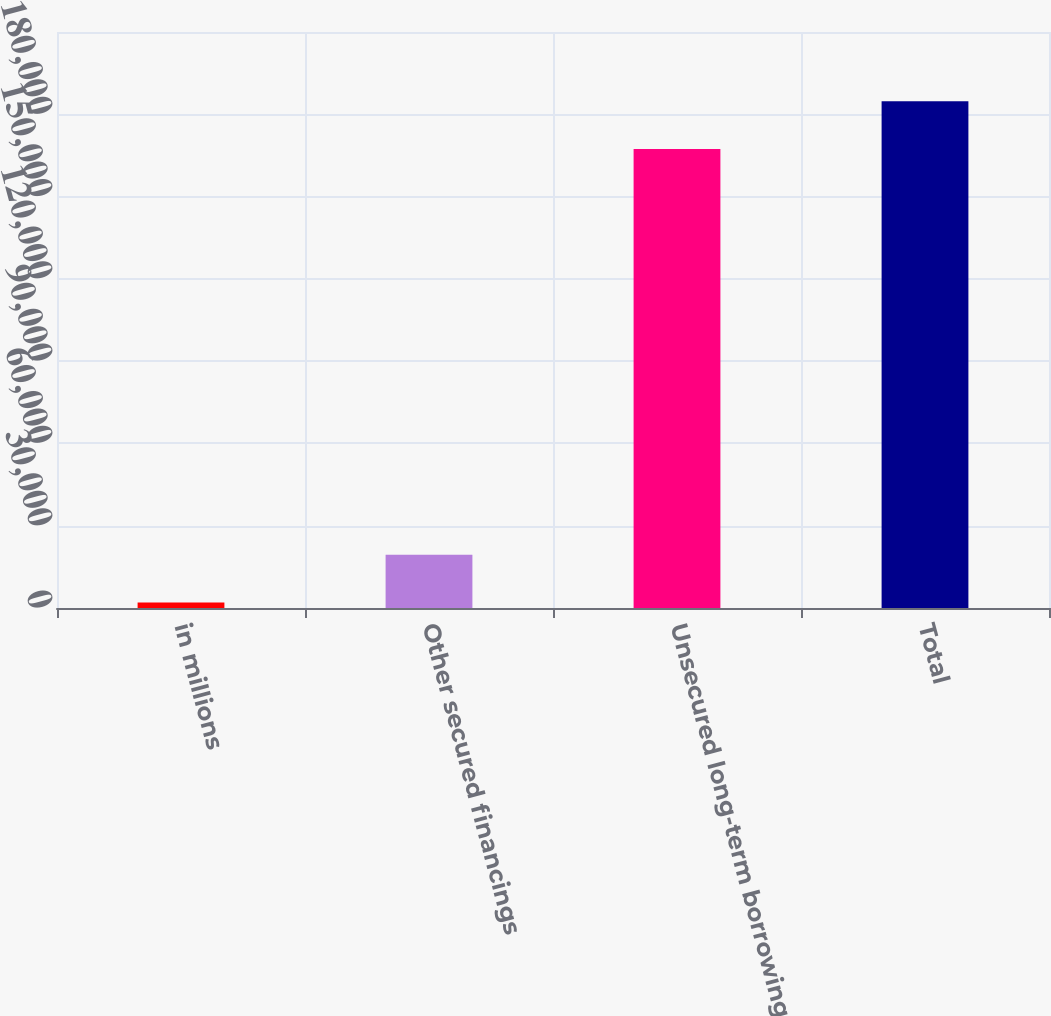<chart> <loc_0><loc_0><loc_500><loc_500><bar_chart><fcel>in millions<fcel>Other secured financings<fcel>Unsecured long-term borrowings<fcel>Total<nl><fcel>2012<fcel>19437.8<fcel>167305<fcel>184731<nl></chart> 